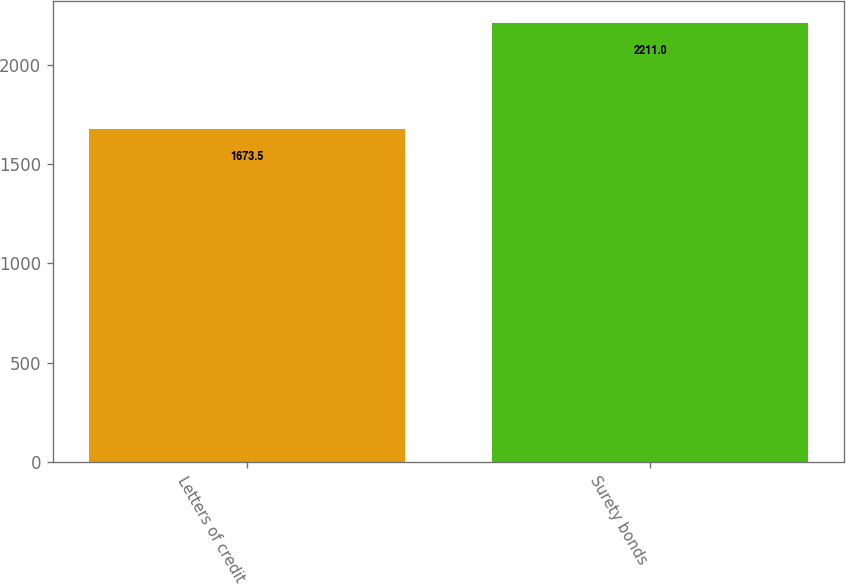Convert chart to OTSL. <chart><loc_0><loc_0><loc_500><loc_500><bar_chart><fcel>Letters of credit<fcel>Surety bonds<nl><fcel>1673.5<fcel>2211<nl></chart> 